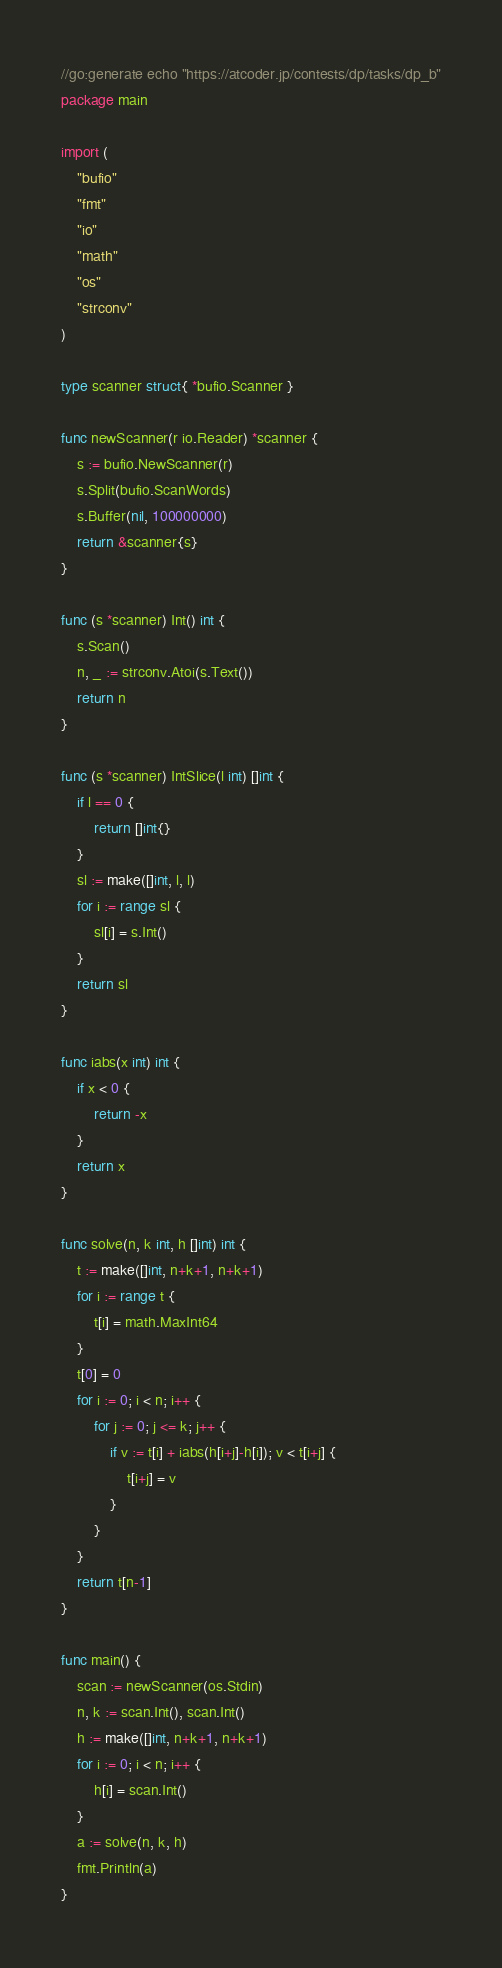Convert code to text. <code><loc_0><loc_0><loc_500><loc_500><_Go_>//go:generate echo "https://atcoder.jp/contests/dp/tasks/dp_b"
package main

import (
	"bufio"
	"fmt"
	"io"
	"math"
	"os"
	"strconv"
)

type scanner struct{ *bufio.Scanner }

func newScanner(r io.Reader) *scanner {
	s := bufio.NewScanner(r)
	s.Split(bufio.ScanWords)
	s.Buffer(nil, 100000000)
	return &scanner{s}
}

func (s *scanner) Int() int {
	s.Scan()
	n, _ := strconv.Atoi(s.Text())
	return n
}

func (s *scanner) IntSlice(l int) []int {
	if l == 0 {
		return []int{}
	}
	sl := make([]int, l, l)
	for i := range sl {
		sl[i] = s.Int()
	}
	return sl
}

func iabs(x int) int {
	if x < 0 {
		return -x
	}
	return x
}

func solve(n, k int, h []int) int {
	t := make([]int, n+k+1, n+k+1)
	for i := range t {
		t[i] = math.MaxInt64
	}
	t[0] = 0
	for i := 0; i < n; i++ {
		for j := 0; j <= k; j++ {
			if v := t[i] + iabs(h[i+j]-h[i]); v < t[i+j] {
				t[i+j] = v
			}
		}
	}
	return t[n-1]
}

func main() {
	scan := newScanner(os.Stdin)
	n, k := scan.Int(), scan.Int()
	h := make([]int, n+k+1, n+k+1)
	for i := 0; i < n; i++ {
		h[i] = scan.Int()
	}
	a := solve(n, k, h)
	fmt.Println(a)
}
</code> 